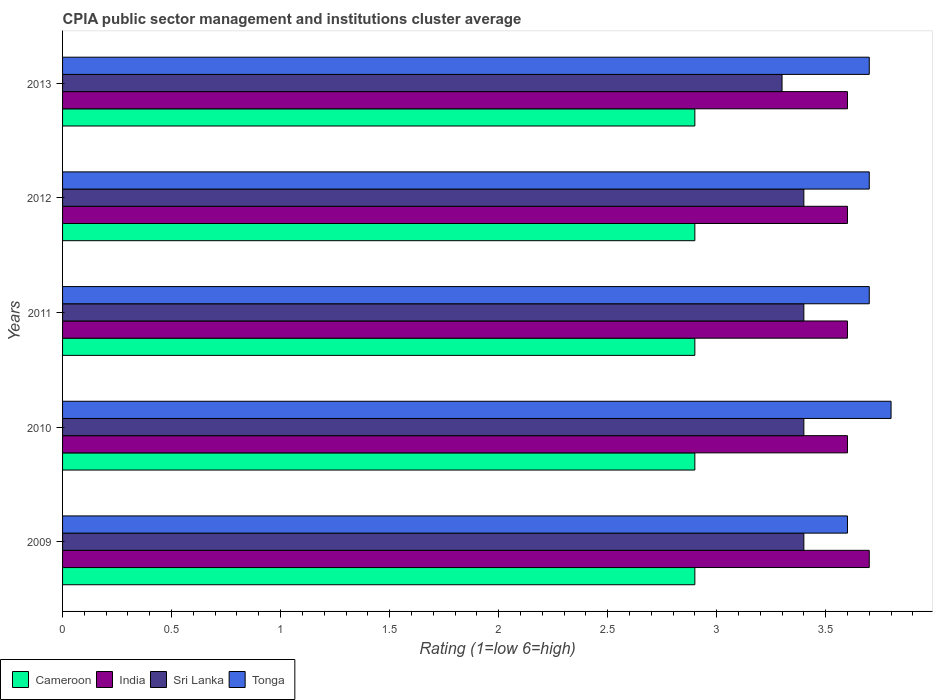How many different coloured bars are there?
Provide a succinct answer. 4. Are the number of bars per tick equal to the number of legend labels?
Keep it short and to the point. Yes. What is the label of the 5th group of bars from the top?
Keep it short and to the point. 2009. In how many cases, is the number of bars for a given year not equal to the number of legend labels?
Give a very brief answer. 0. What is the CPIA rating in Tonga in 2009?
Provide a short and direct response. 3.6. Across all years, what is the minimum CPIA rating in Cameroon?
Provide a short and direct response. 2.9. In which year was the CPIA rating in India minimum?
Offer a terse response. 2010. What is the total CPIA rating in India in the graph?
Your answer should be very brief. 18.1. What is the difference between the CPIA rating in Sri Lanka in 2009 and that in 2011?
Your answer should be very brief. 0. What is the difference between the CPIA rating in India in 2011 and the CPIA rating in Cameroon in 2012?
Keep it short and to the point. 0.7. What is the average CPIA rating in Cameroon per year?
Keep it short and to the point. 2.9. In the year 2011, what is the difference between the CPIA rating in Sri Lanka and CPIA rating in Tonga?
Ensure brevity in your answer.  -0.3. In how many years, is the CPIA rating in Tonga greater than 0.4 ?
Offer a very short reply. 5. What is the difference between the highest and the lowest CPIA rating in Cameroon?
Provide a short and direct response. 0. What does the 4th bar from the top in 2011 represents?
Your response must be concise. Cameroon. What does the 2nd bar from the bottom in 2012 represents?
Provide a succinct answer. India. Is it the case that in every year, the sum of the CPIA rating in India and CPIA rating in Tonga is greater than the CPIA rating in Cameroon?
Provide a short and direct response. Yes. How many bars are there?
Give a very brief answer. 20. How many years are there in the graph?
Offer a very short reply. 5. What is the difference between two consecutive major ticks on the X-axis?
Offer a terse response. 0.5. Are the values on the major ticks of X-axis written in scientific E-notation?
Your answer should be compact. No. Does the graph contain grids?
Offer a very short reply. No. How are the legend labels stacked?
Your response must be concise. Horizontal. What is the title of the graph?
Keep it short and to the point. CPIA public sector management and institutions cluster average. Does "Vietnam" appear as one of the legend labels in the graph?
Your answer should be compact. No. What is the label or title of the Y-axis?
Keep it short and to the point. Years. What is the Rating (1=low 6=high) of Tonga in 2009?
Keep it short and to the point. 3.6. What is the Rating (1=low 6=high) of Cameroon in 2010?
Offer a very short reply. 2.9. What is the Rating (1=low 6=high) in Sri Lanka in 2010?
Your response must be concise. 3.4. What is the Rating (1=low 6=high) of Tonga in 2010?
Your answer should be very brief. 3.8. What is the Rating (1=low 6=high) in India in 2011?
Offer a terse response. 3.6. What is the Rating (1=low 6=high) in Tonga in 2011?
Keep it short and to the point. 3.7. What is the Rating (1=low 6=high) in Cameroon in 2012?
Provide a succinct answer. 2.9. What is the Rating (1=low 6=high) in India in 2012?
Offer a very short reply. 3.6. What is the Rating (1=low 6=high) in Sri Lanka in 2012?
Make the answer very short. 3.4. What is the Rating (1=low 6=high) in Tonga in 2012?
Give a very brief answer. 3.7. What is the Rating (1=low 6=high) in Cameroon in 2013?
Offer a very short reply. 2.9. What is the Rating (1=low 6=high) in India in 2013?
Keep it short and to the point. 3.6. What is the Rating (1=low 6=high) of Tonga in 2013?
Provide a succinct answer. 3.7. Across all years, what is the maximum Rating (1=low 6=high) in Cameroon?
Offer a very short reply. 2.9. Across all years, what is the maximum Rating (1=low 6=high) in India?
Offer a terse response. 3.7. Across all years, what is the maximum Rating (1=low 6=high) of Tonga?
Your answer should be very brief. 3.8. Across all years, what is the minimum Rating (1=low 6=high) of India?
Make the answer very short. 3.6. Across all years, what is the minimum Rating (1=low 6=high) in Tonga?
Provide a short and direct response. 3.6. What is the total Rating (1=low 6=high) of Sri Lanka in the graph?
Your answer should be very brief. 16.9. What is the difference between the Rating (1=low 6=high) of India in 2009 and that in 2010?
Ensure brevity in your answer.  0.1. What is the difference between the Rating (1=low 6=high) of Sri Lanka in 2009 and that in 2010?
Make the answer very short. 0. What is the difference between the Rating (1=low 6=high) of Tonga in 2009 and that in 2010?
Your answer should be very brief. -0.2. What is the difference between the Rating (1=low 6=high) of Cameroon in 2009 and that in 2011?
Keep it short and to the point. 0. What is the difference between the Rating (1=low 6=high) of Sri Lanka in 2009 and that in 2011?
Provide a short and direct response. 0. What is the difference between the Rating (1=low 6=high) in Tonga in 2009 and that in 2011?
Offer a terse response. -0.1. What is the difference between the Rating (1=low 6=high) of Cameroon in 2009 and that in 2012?
Your response must be concise. 0. What is the difference between the Rating (1=low 6=high) in India in 2009 and that in 2012?
Offer a terse response. 0.1. What is the difference between the Rating (1=low 6=high) of Tonga in 2009 and that in 2012?
Your answer should be very brief. -0.1. What is the difference between the Rating (1=low 6=high) of Tonga in 2009 and that in 2013?
Offer a very short reply. -0.1. What is the difference between the Rating (1=low 6=high) in India in 2010 and that in 2011?
Provide a succinct answer. 0. What is the difference between the Rating (1=low 6=high) of Sri Lanka in 2010 and that in 2011?
Your answer should be compact. 0. What is the difference between the Rating (1=low 6=high) in Sri Lanka in 2010 and that in 2012?
Your response must be concise. 0. What is the difference between the Rating (1=low 6=high) in India in 2010 and that in 2013?
Your answer should be very brief. 0. What is the difference between the Rating (1=low 6=high) in Sri Lanka in 2011 and that in 2012?
Your answer should be compact. 0. What is the difference between the Rating (1=low 6=high) of Tonga in 2011 and that in 2012?
Provide a short and direct response. 0. What is the difference between the Rating (1=low 6=high) of Cameroon in 2011 and that in 2013?
Provide a short and direct response. 0. What is the difference between the Rating (1=low 6=high) in India in 2011 and that in 2013?
Make the answer very short. 0. What is the difference between the Rating (1=low 6=high) of Cameroon in 2009 and the Rating (1=low 6=high) of Sri Lanka in 2010?
Ensure brevity in your answer.  -0.5. What is the difference between the Rating (1=low 6=high) of Cameroon in 2009 and the Rating (1=low 6=high) of Tonga in 2010?
Give a very brief answer. -0.9. What is the difference between the Rating (1=low 6=high) in India in 2009 and the Rating (1=low 6=high) in Sri Lanka in 2010?
Your response must be concise. 0.3. What is the difference between the Rating (1=low 6=high) of Cameroon in 2009 and the Rating (1=low 6=high) of India in 2011?
Your response must be concise. -0.7. What is the difference between the Rating (1=low 6=high) of Cameroon in 2009 and the Rating (1=low 6=high) of Sri Lanka in 2011?
Your answer should be very brief. -0.5. What is the difference between the Rating (1=low 6=high) in India in 2009 and the Rating (1=low 6=high) in Tonga in 2011?
Provide a short and direct response. 0. What is the difference between the Rating (1=low 6=high) of Cameroon in 2009 and the Rating (1=low 6=high) of India in 2012?
Make the answer very short. -0.7. What is the difference between the Rating (1=low 6=high) of Cameroon in 2009 and the Rating (1=low 6=high) of Sri Lanka in 2012?
Give a very brief answer. -0.5. What is the difference between the Rating (1=low 6=high) of India in 2009 and the Rating (1=low 6=high) of Tonga in 2012?
Keep it short and to the point. 0. What is the difference between the Rating (1=low 6=high) in Cameroon in 2009 and the Rating (1=low 6=high) in India in 2013?
Your response must be concise. -0.7. What is the difference between the Rating (1=low 6=high) in Cameroon in 2009 and the Rating (1=low 6=high) in Sri Lanka in 2013?
Offer a very short reply. -0.4. What is the difference between the Rating (1=low 6=high) of India in 2009 and the Rating (1=low 6=high) of Sri Lanka in 2013?
Your response must be concise. 0.4. What is the difference between the Rating (1=low 6=high) in India in 2009 and the Rating (1=low 6=high) in Tonga in 2013?
Your answer should be very brief. 0. What is the difference between the Rating (1=low 6=high) of Cameroon in 2010 and the Rating (1=low 6=high) of India in 2011?
Provide a succinct answer. -0.7. What is the difference between the Rating (1=low 6=high) in Cameroon in 2010 and the Rating (1=low 6=high) in Tonga in 2011?
Keep it short and to the point. -0.8. What is the difference between the Rating (1=low 6=high) of Sri Lanka in 2010 and the Rating (1=low 6=high) of Tonga in 2011?
Your response must be concise. -0.3. What is the difference between the Rating (1=low 6=high) of Cameroon in 2010 and the Rating (1=low 6=high) of Sri Lanka in 2012?
Offer a very short reply. -0.5. What is the difference between the Rating (1=low 6=high) in India in 2010 and the Rating (1=low 6=high) in Sri Lanka in 2012?
Your answer should be compact. 0.2. What is the difference between the Rating (1=low 6=high) of Cameroon in 2010 and the Rating (1=low 6=high) of Tonga in 2013?
Offer a terse response. -0.8. What is the difference between the Rating (1=low 6=high) in India in 2010 and the Rating (1=low 6=high) in Tonga in 2013?
Provide a short and direct response. -0.1. What is the difference between the Rating (1=low 6=high) in Sri Lanka in 2010 and the Rating (1=low 6=high) in Tonga in 2013?
Make the answer very short. -0.3. What is the difference between the Rating (1=low 6=high) in Cameroon in 2011 and the Rating (1=low 6=high) in India in 2012?
Give a very brief answer. -0.7. What is the difference between the Rating (1=low 6=high) of Cameroon in 2011 and the Rating (1=low 6=high) of Sri Lanka in 2012?
Your answer should be compact. -0.5. What is the difference between the Rating (1=low 6=high) of India in 2011 and the Rating (1=low 6=high) of Tonga in 2012?
Provide a short and direct response. -0.1. What is the difference between the Rating (1=low 6=high) in Cameroon in 2011 and the Rating (1=low 6=high) in Sri Lanka in 2013?
Your answer should be compact. -0.4. What is the difference between the Rating (1=low 6=high) in Cameroon in 2011 and the Rating (1=low 6=high) in Tonga in 2013?
Offer a very short reply. -0.8. What is the difference between the Rating (1=low 6=high) in India in 2011 and the Rating (1=low 6=high) in Sri Lanka in 2013?
Provide a succinct answer. 0.3. What is the difference between the Rating (1=low 6=high) in India in 2011 and the Rating (1=low 6=high) in Tonga in 2013?
Give a very brief answer. -0.1. What is the difference between the Rating (1=low 6=high) of Sri Lanka in 2011 and the Rating (1=low 6=high) of Tonga in 2013?
Provide a short and direct response. -0.3. What is the difference between the Rating (1=low 6=high) of Cameroon in 2012 and the Rating (1=low 6=high) of Sri Lanka in 2013?
Keep it short and to the point. -0.4. What is the difference between the Rating (1=low 6=high) of India in 2012 and the Rating (1=low 6=high) of Tonga in 2013?
Make the answer very short. -0.1. What is the difference between the Rating (1=low 6=high) in Sri Lanka in 2012 and the Rating (1=low 6=high) in Tonga in 2013?
Offer a very short reply. -0.3. What is the average Rating (1=low 6=high) of Cameroon per year?
Offer a very short reply. 2.9. What is the average Rating (1=low 6=high) in India per year?
Your answer should be compact. 3.62. What is the average Rating (1=low 6=high) of Sri Lanka per year?
Your response must be concise. 3.38. In the year 2009, what is the difference between the Rating (1=low 6=high) in Cameroon and Rating (1=low 6=high) in Tonga?
Give a very brief answer. -0.7. In the year 2009, what is the difference between the Rating (1=low 6=high) of India and Rating (1=low 6=high) of Sri Lanka?
Ensure brevity in your answer.  0.3. In the year 2009, what is the difference between the Rating (1=low 6=high) in India and Rating (1=low 6=high) in Tonga?
Ensure brevity in your answer.  0.1. In the year 2009, what is the difference between the Rating (1=low 6=high) in Sri Lanka and Rating (1=low 6=high) in Tonga?
Make the answer very short. -0.2. In the year 2010, what is the difference between the Rating (1=low 6=high) in Cameroon and Rating (1=low 6=high) in Sri Lanka?
Provide a short and direct response. -0.5. In the year 2010, what is the difference between the Rating (1=low 6=high) of Cameroon and Rating (1=low 6=high) of Tonga?
Offer a very short reply. -0.9. In the year 2010, what is the difference between the Rating (1=low 6=high) of Sri Lanka and Rating (1=low 6=high) of Tonga?
Provide a short and direct response. -0.4. In the year 2011, what is the difference between the Rating (1=low 6=high) of Cameroon and Rating (1=low 6=high) of Sri Lanka?
Ensure brevity in your answer.  -0.5. In the year 2011, what is the difference between the Rating (1=low 6=high) of Cameroon and Rating (1=low 6=high) of Tonga?
Provide a succinct answer. -0.8. In the year 2011, what is the difference between the Rating (1=low 6=high) of India and Rating (1=low 6=high) of Sri Lanka?
Make the answer very short. 0.2. In the year 2011, what is the difference between the Rating (1=low 6=high) in Sri Lanka and Rating (1=low 6=high) in Tonga?
Give a very brief answer. -0.3. In the year 2012, what is the difference between the Rating (1=low 6=high) in Cameroon and Rating (1=low 6=high) in India?
Your answer should be very brief. -0.7. In the year 2012, what is the difference between the Rating (1=low 6=high) of Cameroon and Rating (1=low 6=high) of Sri Lanka?
Your answer should be very brief. -0.5. In the year 2012, what is the difference between the Rating (1=low 6=high) in Cameroon and Rating (1=low 6=high) in Tonga?
Your response must be concise. -0.8. In the year 2012, what is the difference between the Rating (1=low 6=high) in Sri Lanka and Rating (1=low 6=high) in Tonga?
Provide a short and direct response. -0.3. In the year 2013, what is the difference between the Rating (1=low 6=high) in Cameroon and Rating (1=low 6=high) in India?
Your answer should be compact. -0.7. In the year 2013, what is the difference between the Rating (1=low 6=high) of Cameroon and Rating (1=low 6=high) of Sri Lanka?
Offer a terse response. -0.4. In the year 2013, what is the difference between the Rating (1=low 6=high) of Cameroon and Rating (1=low 6=high) of Tonga?
Offer a terse response. -0.8. In the year 2013, what is the difference between the Rating (1=low 6=high) of India and Rating (1=low 6=high) of Sri Lanka?
Provide a short and direct response. 0.3. In the year 2013, what is the difference between the Rating (1=low 6=high) of India and Rating (1=low 6=high) of Tonga?
Ensure brevity in your answer.  -0.1. What is the ratio of the Rating (1=low 6=high) in Cameroon in 2009 to that in 2010?
Keep it short and to the point. 1. What is the ratio of the Rating (1=low 6=high) of India in 2009 to that in 2010?
Make the answer very short. 1.03. What is the ratio of the Rating (1=low 6=high) of Cameroon in 2009 to that in 2011?
Offer a terse response. 1. What is the ratio of the Rating (1=low 6=high) of India in 2009 to that in 2011?
Provide a short and direct response. 1.03. What is the ratio of the Rating (1=low 6=high) of Sri Lanka in 2009 to that in 2011?
Provide a succinct answer. 1. What is the ratio of the Rating (1=low 6=high) of India in 2009 to that in 2012?
Give a very brief answer. 1.03. What is the ratio of the Rating (1=low 6=high) of Sri Lanka in 2009 to that in 2012?
Make the answer very short. 1. What is the ratio of the Rating (1=low 6=high) in Cameroon in 2009 to that in 2013?
Offer a terse response. 1. What is the ratio of the Rating (1=low 6=high) in India in 2009 to that in 2013?
Provide a short and direct response. 1.03. What is the ratio of the Rating (1=low 6=high) in Sri Lanka in 2009 to that in 2013?
Provide a short and direct response. 1.03. What is the ratio of the Rating (1=low 6=high) of India in 2010 to that in 2011?
Your response must be concise. 1. What is the ratio of the Rating (1=low 6=high) in India in 2010 to that in 2012?
Your answer should be compact. 1. What is the ratio of the Rating (1=low 6=high) in Sri Lanka in 2010 to that in 2012?
Your answer should be very brief. 1. What is the ratio of the Rating (1=low 6=high) in Tonga in 2010 to that in 2012?
Offer a terse response. 1.03. What is the ratio of the Rating (1=low 6=high) of Sri Lanka in 2010 to that in 2013?
Offer a very short reply. 1.03. What is the ratio of the Rating (1=low 6=high) in Tonga in 2010 to that in 2013?
Give a very brief answer. 1.03. What is the ratio of the Rating (1=low 6=high) of India in 2011 to that in 2012?
Your response must be concise. 1. What is the ratio of the Rating (1=low 6=high) in Sri Lanka in 2011 to that in 2012?
Provide a short and direct response. 1. What is the ratio of the Rating (1=low 6=high) in Tonga in 2011 to that in 2012?
Give a very brief answer. 1. What is the ratio of the Rating (1=low 6=high) of Cameroon in 2011 to that in 2013?
Offer a very short reply. 1. What is the ratio of the Rating (1=low 6=high) of India in 2011 to that in 2013?
Keep it short and to the point. 1. What is the ratio of the Rating (1=low 6=high) of Sri Lanka in 2011 to that in 2013?
Your answer should be compact. 1.03. What is the ratio of the Rating (1=low 6=high) of India in 2012 to that in 2013?
Make the answer very short. 1. What is the ratio of the Rating (1=low 6=high) in Sri Lanka in 2012 to that in 2013?
Your answer should be compact. 1.03. What is the ratio of the Rating (1=low 6=high) of Tonga in 2012 to that in 2013?
Provide a succinct answer. 1. What is the difference between the highest and the second highest Rating (1=low 6=high) of India?
Your answer should be compact. 0.1. What is the difference between the highest and the lowest Rating (1=low 6=high) in Cameroon?
Make the answer very short. 0. What is the difference between the highest and the lowest Rating (1=low 6=high) of India?
Keep it short and to the point. 0.1. What is the difference between the highest and the lowest Rating (1=low 6=high) of Sri Lanka?
Give a very brief answer. 0.1. What is the difference between the highest and the lowest Rating (1=low 6=high) of Tonga?
Your response must be concise. 0.2. 